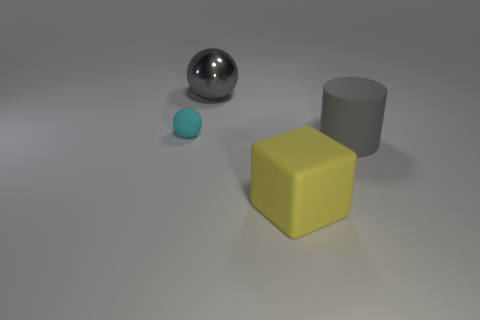There is another object that is the same shape as the large gray metal thing; what is it made of?
Your answer should be very brief. Rubber. Is the material of the big gray thing on the right side of the gray metal sphere the same as the large cube?
Provide a short and direct response. Yes. Is the number of large gray things that are behind the small object greater than the number of rubber balls that are in front of the big yellow matte object?
Make the answer very short. Yes. What size is the gray shiny thing?
Offer a very short reply. Large. What is the shape of the cyan object that is the same material as the large cylinder?
Offer a very short reply. Sphere. There is a gray thing behind the tiny cyan matte sphere; does it have the same shape as the big yellow thing?
Keep it short and to the point. No. What number of objects are either yellow things or purple balls?
Keep it short and to the point. 1. The object that is both left of the big yellow rubber cube and right of the matte ball is made of what material?
Make the answer very short. Metal. Do the gray sphere and the matte cylinder have the same size?
Your answer should be very brief. Yes. How big is the sphere in front of the big gray object behind the rubber sphere?
Make the answer very short. Small. 